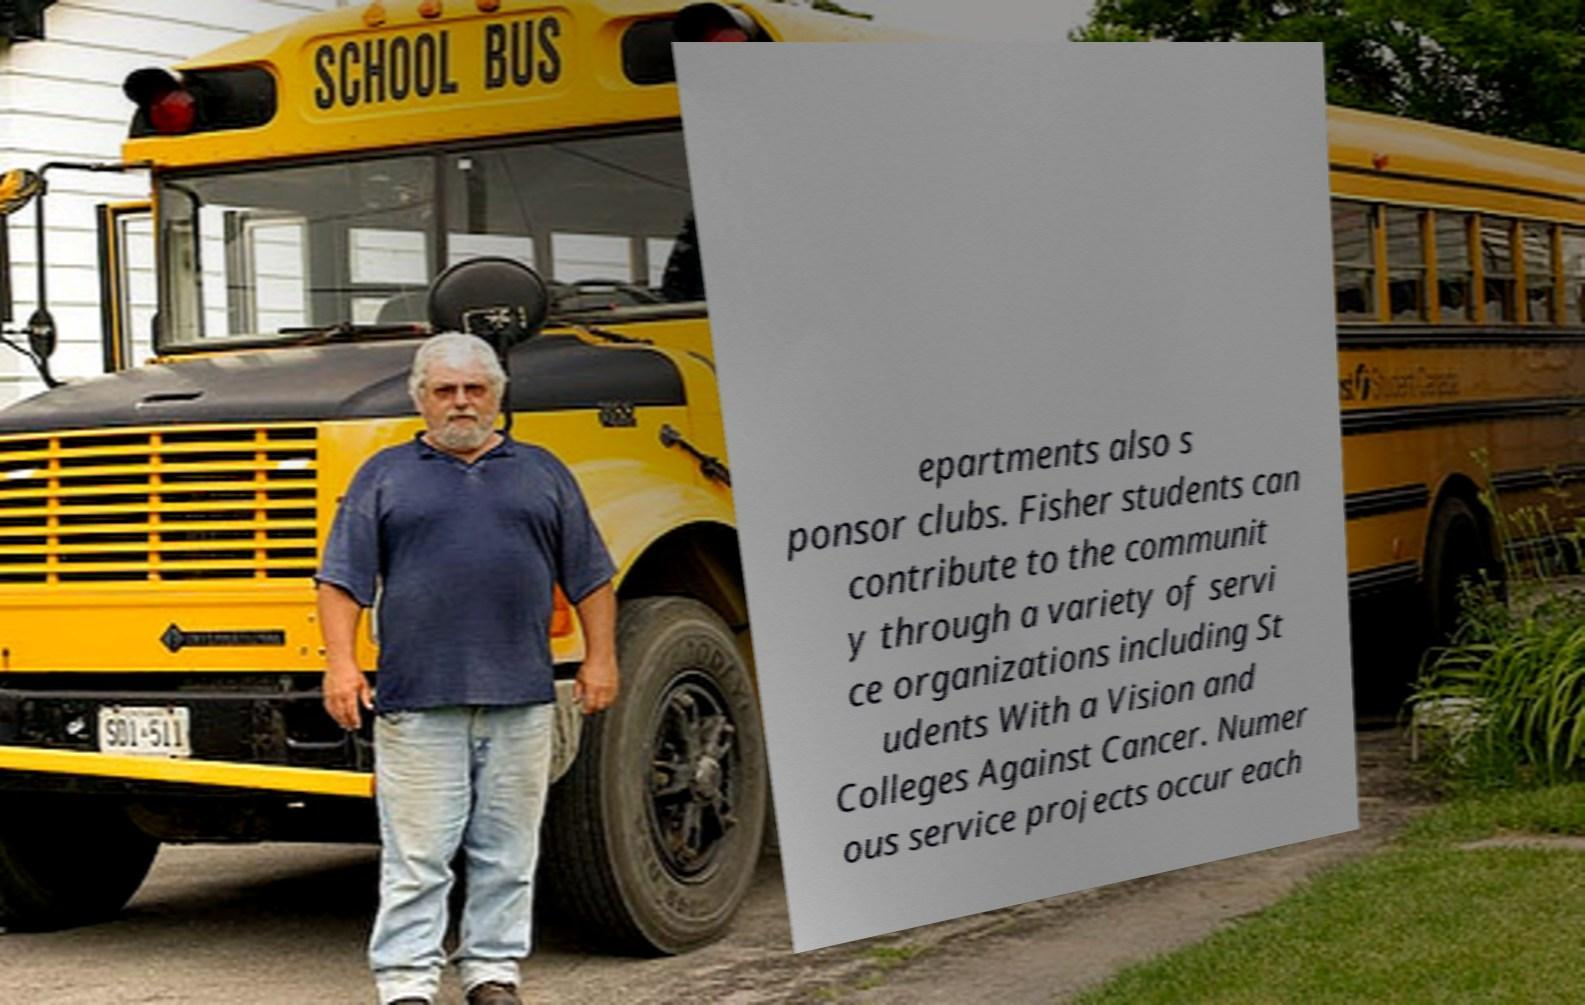Could you extract and type out the text from this image? epartments also s ponsor clubs. Fisher students can contribute to the communit y through a variety of servi ce organizations including St udents With a Vision and Colleges Against Cancer. Numer ous service projects occur each 